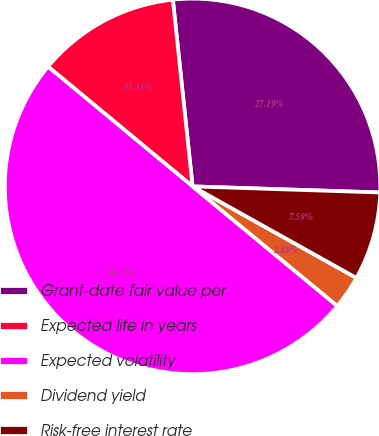Convert chart to OTSL. <chart><loc_0><loc_0><loc_500><loc_500><pie_chart><fcel>Grant-date fair value per<fcel>Expected life in years<fcel>Expected volatility<fcel>Dividend yield<fcel>Risk-free interest rate<nl><fcel>27.19%<fcel>12.31%<fcel>50.02%<fcel>2.88%<fcel>7.59%<nl></chart> 